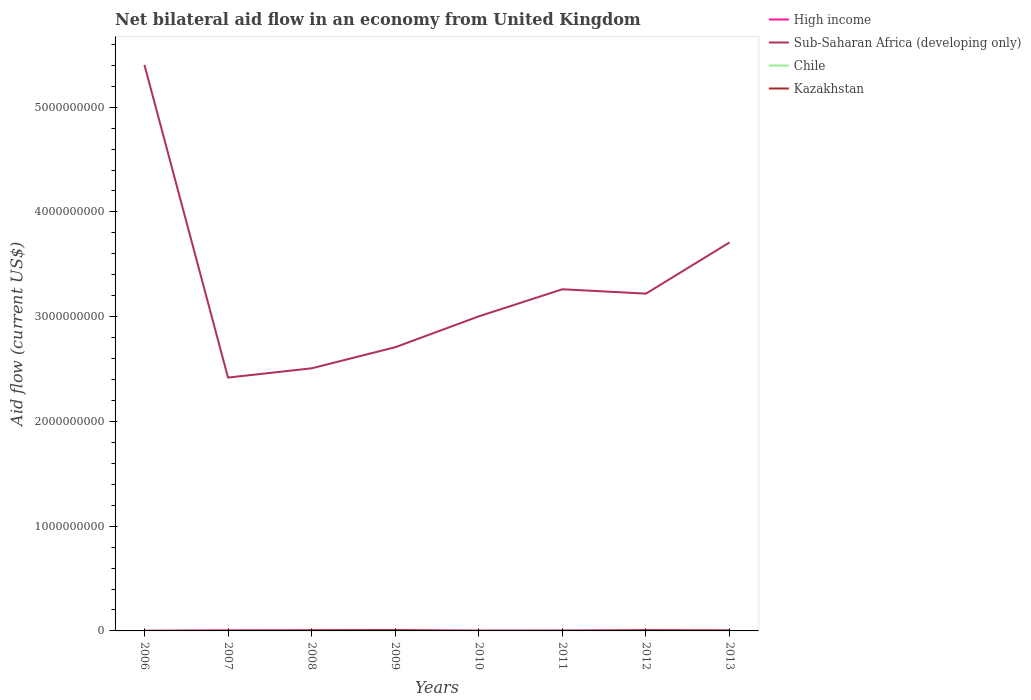Does the line corresponding to Kazakhstan intersect with the line corresponding to High income?
Keep it short and to the point. Yes. What is the total net bilateral aid flow in Chile in the graph?
Offer a terse response. -7.00e+04. What is the difference between the highest and the second highest net bilateral aid flow in Sub-Saharan Africa (developing only)?
Offer a terse response. 2.99e+09. Is the net bilateral aid flow in Kazakhstan strictly greater than the net bilateral aid flow in Sub-Saharan Africa (developing only) over the years?
Give a very brief answer. Yes. What is the difference between two consecutive major ticks on the Y-axis?
Keep it short and to the point. 1.00e+09. How many legend labels are there?
Keep it short and to the point. 4. How are the legend labels stacked?
Your answer should be compact. Vertical. What is the title of the graph?
Make the answer very short. Net bilateral aid flow in an economy from United Kingdom. What is the label or title of the X-axis?
Offer a terse response. Years. What is the label or title of the Y-axis?
Provide a succinct answer. Aid flow (current US$). What is the Aid flow (current US$) of High income in 2006?
Your answer should be compact. 1.64e+06. What is the Aid flow (current US$) in Sub-Saharan Africa (developing only) in 2006?
Provide a short and direct response. 5.40e+09. What is the Aid flow (current US$) of Chile in 2006?
Offer a terse response. 8.60e+05. What is the Aid flow (current US$) of High income in 2007?
Provide a short and direct response. 5.97e+06. What is the Aid flow (current US$) of Sub-Saharan Africa (developing only) in 2007?
Ensure brevity in your answer.  2.42e+09. What is the Aid flow (current US$) in Chile in 2007?
Your answer should be very brief. 5.20e+05. What is the Aid flow (current US$) in High income in 2008?
Your response must be concise. 3.69e+06. What is the Aid flow (current US$) of Sub-Saharan Africa (developing only) in 2008?
Your answer should be very brief. 2.51e+09. What is the Aid flow (current US$) of Kazakhstan in 2008?
Provide a short and direct response. 5.42e+06. What is the Aid flow (current US$) of High income in 2009?
Your response must be concise. 4.25e+06. What is the Aid flow (current US$) of Sub-Saharan Africa (developing only) in 2009?
Offer a very short reply. 2.71e+09. What is the Aid flow (current US$) in Chile in 2009?
Offer a very short reply. 5.90e+05. What is the Aid flow (current US$) of Kazakhstan in 2009?
Your response must be concise. 6.95e+06. What is the Aid flow (current US$) of High income in 2010?
Provide a short and direct response. 3.12e+06. What is the Aid flow (current US$) of Sub-Saharan Africa (developing only) in 2010?
Your response must be concise. 3.00e+09. What is the Aid flow (current US$) of Kazakhstan in 2010?
Your response must be concise. 3.40e+05. What is the Aid flow (current US$) in High income in 2011?
Your response must be concise. 1.04e+06. What is the Aid flow (current US$) of Sub-Saharan Africa (developing only) in 2011?
Provide a succinct answer. 3.26e+09. What is the Aid flow (current US$) in Chile in 2011?
Your answer should be very brief. 5.50e+05. What is the Aid flow (current US$) in Kazakhstan in 2011?
Keep it short and to the point. 2.73e+06. What is the Aid flow (current US$) in High income in 2012?
Your response must be concise. 5.89e+06. What is the Aid flow (current US$) of Sub-Saharan Africa (developing only) in 2012?
Give a very brief answer. 3.22e+09. What is the Aid flow (current US$) of Chile in 2012?
Offer a terse response. 1.40e+06. What is the Aid flow (current US$) in Kazakhstan in 2012?
Your answer should be compact. 5.22e+06. What is the Aid flow (current US$) of High income in 2013?
Offer a very short reply. 6.59e+06. What is the Aid flow (current US$) of Sub-Saharan Africa (developing only) in 2013?
Offer a terse response. 3.71e+09. What is the Aid flow (current US$) in Chile in 2013?
Offer a very short reply. 3.09e+06. What is the Aid flow (current US$) in Kazakhstan in 2013?
Offer a terse response. 2.80e+06. Across all years, what is the maximum Aid flow (current US$) of High income?
Give a very brief answer. 6.59e+06. Across all years, what is the maximum Aid flow (current US$) in Sub-Saharan Africa (developing only)?
Your answer should be compact. 5.40e+09. Across all years, what is the maximum Aid flow (current US$) of Chile?
Provide a short and direct response. 3.09e+06. Across all years, what is the maximum Aid flow (current US$) in Kazakhstan?
Provide a short and direct response. 6.95e+06. Across all years, what is the minimum Aid flow (current US$) of High income?
Provide a short and direct response. 1.04e+06. Across all years, what is the minimum Aid flow (current US$) in Sub-Saharan Africa (developing only)?
Your answer should be compact. 2.42e+09. Across all years, what is the minimum Aid flow (current US$) in Chile?
Provide a short and direct response. 4.80e+05. What is the total Aid flow (current US$) of High income in the graph?
Provide a succinct answer. 3.22e+07. What is the total Aid flow (current US$) in Sub-Saharan Africa (developing only) in the graph?
Offer a terse response. 2.62e+1. What is the total Aid flow (current US$) in Chile in the graph?
Give a very brief answer. 8.15e+06. What is the total Aid flow (current US$) in Kazakhstan in the graph?
Ensure brevity in your answer.  2.43e+07. What is the difference between the Aid flow (current US$) in High income in 2006 and that in 2007?
Make the answer very short. -4.33e+06. What is the difference between the Aid flow (current US$) in Sub-Saharan Africa (developing only) in 2006 and that in 2007?
Ensure brevity in your answer.  2.99e+09. What is the difference between the Aid flow (current US$) of Chile in 2006 and that in 2007?
Offer a terse response. 3.40e+05. What is the difference between the Aid flow (current US$) in Kazakhstan in 2006 and that in 2007?
Your answer should be very brief. -4.90e+05. What is the difference between the Aid flow (current US$) in High income in 2006 and that in 2008?
Offer a very short reply. -2.05e+06. What is the difference between the Aid flow (current US$) of Sub-Saharan Africa (developing only) in 2006 and that in 2008?
Your answer should be very brief. 2.90e+09. What is the difference between the Aid flow (current US$) in Kazakhstan in 2006 and that in 2008?
Ensure brevity in your answer.  -5.25e+06. What is the difference between the Aid flow (current US$) in High income in 2006 and that in 2009?
Your response must be concise. -2.61e+06. What is the difference between the Aid flow (current US$) in Sub-Saharan Africa (developing only) in 2006 and that in 2009?
Make the answer very short. 2.70e+09. What is the difference between the Aid flow (current US$) in Kazakhstan in 2006 and that in 2009?
Your answer should be compact. -6.78e+06. What is the difference between the Aid flow (current US$) in High income in 2006 and that in 2010?
Provide a short and direct response. -1.48e+06. What is the difference between the Aid flow (current US$) of Sub-Saharan Africa (developing only) in 2006 and that in 2010?
Offer a very short reply. 2.40e+09. What is the difference between the Aid flow (current US$) in Kazakhstan in 2006 and that in 2010?
Provide a succinct answer. -1.70e+05. What is the difference between the Aid flow (current US$) in High income in 2006 and that in 2011?
Make the answer very short. 6.00e+05. What is the difference between the Aid flow (current US$) of Sub-Saharan Africa (developing only) in 2006 and that in 2011?
Provide a succinct answer. 2.14e+09. What is the difference between the Aid flow (current US$) of Chile in 2006 and that in 2011?
Make the answer very short. 3.10e+05. What is the difference between the Aid flow (current US$) in Kazakhstan in 2006 and that in 2011?
Offer a terse response. -2.56e+06. What is the difference between the Aid flow (current US$) in High income in 2006 and that in 2012?
Your response must be concise. -4.25e+06. What is the difference between the Aid flow (current US$) of Sub-Saharan Africa (developing only) in 2006 and that in 2012?
Your answer should be compact. 2.18e+09. What is the difference between the Aid flow (current US$) in Chile in 2006 and that in 2012?
Keep it short and to the point. -5.40e+05. What is the difference between the Aid flow (current US$) of Kazakhstan in 2006 and that in 2012?
Give a very brief answer. -5.05e+06. What is the difference between the Aid flow (current US$) in High income in 2006 and that in 2013?
Offer a terse response. -4.95e+06. What is the difference between the Aid flow (current US$) of Sub-Saharan Africa (developing only) in 2006 and that in 2013?
Offer a terse response. 1.69e+09. What is the difference between the Aid flow (current US$) of Chile in 2006 and that in 2013?
Offer a terse response. -2.23e+06. What is the difference between the Aid flow (current US$) of Kazakhstan in 2006 and that in 2013?
Provide a succinct answer. -2.63e+06. What is the difference between the Aid flow (current US$) of High income in 2007 and that in 2008?
Give a very brief answer. 2.28e+06. What is the difference between the Aid flow (current US$) in Sub-Saharan Africa (developing only) in 2007 and that in 2008?
Give a very brief answer. -8.83e+07. What is the difference between the Aid flow (current US$) of Kazakhstan in 2007 and that in 2008?
Provide a succinct answer. -4.76e+06. What is the difference between the Aid flow (current US$) of High income in 2007 and that in 2009?
Keep it short and to the point. 1.72e+06. What is the difference between the Aid flow (current US$) of Sub-Saharan Africa (developing only) in 2007 and that in 2009?
Offer a terse response. -2.90e+08. What is the difference between the Aid flow (current US$) of Kazakhstan in 2007 and that in 2009?
Your answer should be very brief. -6.29e+06. What is the difference between the Aid flow (current US$) in High income in 2007 and that in 2010?
Give a very brief answer. 2.85e+06. What is the difference between the Aid flow (current US$) in Sub-Saharan Africa (developing only) in 2007 and that in 2010?
Offer a terse response. -5.85e+08. What is the difference between the Aid flow (current US$) of High income in 2007 and that in 2011?
Make the answer very short. 4.93e+06. What is the difference between the Aid flow (current US$) of Sub-Saharan Africa (developing only) in 2007 and that in 2011?
Provide a succinct answer. -8.43e+08. What is the difference between the Aid flow (current US$) of Chile in 2007 and that in 2011?
Give a very brief answer. -3.00e+04. What is the difference between the Aid flow (current US$) of Kazakhstan in 2007 and that in 2011?
Offer a very short reply. -2.07e+06. What is the difference between the Aid flow (current US$) of Sub-Saharan Africa (developing only) in 2007 and that in 2012?
Give a very brief answer. -8.01e+08. What is the difference between the Aid flow (current US$) in Chile in 2007 and that in 2012?
Provide a succinct answer. -8.80e+05. What is the difference between the Aid flow (current US$) of Kazakhstan in 2007 and that in 2012?
Your answer should be very brief. -4.56e+06. What is the difference between the Aid flow (current US$) in High income in 2007 and that in 2013?
Offer a terse response. -6.20e+05. What is the difference between the Aid flow (current US$) of Sub-Saharan Africa (developing only) in 2007 and that in 2013?
Your response must be concise. -1.29e+09. What is the difference between the Aid flow (current US$) of Chile in 2007 and that in 2013?
Your answer should be compact. -2.57e+06. What is the difference between the Aid flow (current US$) in Kazakhstan in 2007 and that in 2013?
Keep it short and to the point. -2.14e+06. What is the difference between the Aid flow (current US$) in High income in 2008 and that in 2009?
Your response must be concise. -5.60e+05. What is the difference between the Aid flow (current US$) in Sub-Saharan Africa (developing only) in 2008 and that in 2009?
Ensure brevity in your answer.  -2.01e+08. What is the difference between the Aid flow (current US$) in Kazakhstan in 2008 and that in 2009?
Provide a succinct answer. -1.53e+06. What is the difference between the Aid flow (current US$) of High income in 2008 and that in 2010?
Provide a short and direct response. 5.70e+05. What is the difference between the Aid flow (current US$) of Sub-Saharan Africa (developing only) in 2008 and that in 2010?
Make the answer very short. -4.96e+08. What is the difference between the Aid flow (current US$) of Kazakhstan in 2008 and that in 2010?
Provide a short and direct response. 5.08e+06. What is the difference between the Aid flow (current US$) of High income in 2008 and that in 2011?
Ensure brevity in your answer.  2.65e+06. What is the difference between the Aid flow (current US$) of Sub-Saharan Africa (developing only) in 2008 and that in 2011?
Offer a terse response. -7.55e+08. What is the difference between the Aid flow (current US$) in Kazakhstan in 2008 and that in 2011?
Ensure brevity in your answer.  2.69e+06. What is the difference between the Aid flow (current US$) in High income in 2008 and that in 2012?
Offer a very short reply. -2.20e+06. What is the difference between the Aid flow (current US$) in Sub-Saharan Africa (developing only) in 2008 and that in 2012?
Provide a succinct answer. -7.13e+08. What is the difference between the Aid flow (current US$) in Chile in 2008 and that in 2012?
Ensure brevity in your answer.  -9.20e+05. What is the difference between the Aid flow (current US$) of High income in 2008 and that in 2013?
Make the answer very short. -2.90e+06. What is the difference between the Aid flow (current US$) of Sub-Saharan Africa (developing only) in 2008 and that in 2013?
Ensure brevity in your answer.  -1.20e+09. What is the difference between the Aid flow (current US$) in Chile in 2008 and that in 2013?
Offer a terse response. -2.61e+06. What is the difference between the Aid flow (current US$) in Kazakhstan in 2008 and that in 2013?
Give a very brief answer. 2.62e+06. What is the difference between the Aid flow (current US$) in High income in 2009 and that in 2010?
Give a very brief answer. 1.13e+06. What is the difference between the Aid flow (current US$) of Sub-Saharan Africa (developing only) in 2009 and that in 2010?
Give a very brief answer. -2.95e+08. What is the difference between the Aid flow (current US$) in Kazakhstan in 2009 and that in 2010?
Provide a succinct answer. 6.61e+06. What is the difference between the Aid flow (current US$) in High income in 2009 and that in 2011?
Your answer should be very brief. 3.21e+06. What is the difference between the Aid flow (current US$) in Sub-Saharan Africa (developing only) in 2009 and that in 2011?
Ensure brevity in your answer.  -5.53e+08. What is the difference between the Aid flow (current US$) in Kazakhstan in 2009 and that in 2011?
Your answer should be very brief. 4.22e+06. What is the difference between the Aid flow (current US$) of High income in 2009 and that in 2012?
Provide a short and direct response. -1.64e+06. What is the difference between the Aid flow (current US$) of Sub-Saharan Africa (developing only) in 2009 and that in 2012?
Ensure brevity in your answer.  -5.12e+08. What is the difference between the Aid flow (current US$) of Chile in 2009 and that in 2012?
Provide a short and direct response. -8.10e+05. What is the difference between the Aid flow (current US$) in Kazakhstan in 2009 and that in 2012?
Make the answer very short. 1.73e+06. What is the difference between the Aid flow (current US$) in High income in 2009 and that in 2013?
Your answer should be compact. -2.34e+06. What is the difference between the Aid flow (current US$) of Sub-Saharan Africa (developing only) in 2009 and that in 2013?
Give a very brief answer. -1.00e+09. What is the difference between the Aid flow (current US$) in Chile in 2009 and that in 2013?
Offer a terse response. -2.50e+06. What is the difference between the Aid flow (current US$) in Kazakhstan in 2009 and that in 2013?
Give a very brief answer. 4.15e+06. What is the difference between the Aid flow (current US$) in High income in 2010 and that in 2011?
Ensure brevity in your answer.  2.08e+06. What is the difference between the Aid flow (current US$) in Sub-Saharan Africa (developing only) in 2010 and that in 2011?
Give a very brief answer. -2.59e+08. What is the difference between the Aid flow (current US$) in Chile in 2010 and that in 2011?
Make the answer very short. 1.10e+05. What is the difference between the Aid flow (current US$) of Kazakhstan in 2010 and that in 2011?
Offer a very short reply. -2.39e+06. What is the difference between the Aid flow (current US$) in High income in 2010 and that in 2012?
Provide a short and direct response. -2.77e+06. What is the difference between the Aid flow (current US$) of Sub-Saharan Africa (developing only) in 2010 and that in 2012?
Provide a short and direct response. -2.17e+08. What is the difference between the Aid flow (current US$) in Chile in 2010 and that in 2012?
Offer a very short reply. -7.40e+05. What is the difference between the Aid flow (current US$) in Kazakhstan in 2010 and that in 2012?
Provide a short and direct response. -4.88e+06. What is the difference between the Aid flow (current US$) of High income in 2010 and that in 2013?
Provide a short and direct response. -3.47e+06. What is the difference between the Aid flow (current US$) in Sub-Saharan Africa (developing only) in 2010 and that in 2013?
Give a very brief answer. -7.06e+08. What is the difference between the Aid flow (current US$) in Chile in 2010 and that in 2013?
Keep it short and to the point. -2.43e+06. What is the difference between the Aid flow (current US$) in Kazakhstan in 2010 and that in 2013?
Offer a very short reply. -2.46e+06. What is the difference between the Aid flow (current US$) of High income in 2011 and that in 2012?
Offer a very short reply. -4.85e+06. What is the difference between the Aid flow (current US$) in Sub-Saharan Africa (developing only) in 2011 and that in 2012?
Offer a very short reply. 4.16e+07. What is the difference between the Aid flow (current US$) in Chile in 2011 and that in 2012?
Make the answer very short. -8.50e+05. What is the difference between the Aid flow (current US$) in Kazakhstan in 2011 and that in 2012?
Keep it short and to the point. -2.49e+06. What is the difference between the Aid flow (current US$) of High income in 2011 and that in 2013?
Your answer should be compact. -5.55e+06. What is the difference between the Aid flow (current US$) in Sub-Saharan Africa (developing only) in 2011 and that in 2013?
Your answer should be compact. -4.47e+08. What is the difference between the Aid flow (current US$) of Chile in 2011 and that in 2013?
Give a very brief answer. -2.54e+06. What is the difference between the Aid flow (current US$) in Kazakhstan in 2011 and that in 2013?
Give a very brief answer. -7.00e+04. What is the difference between the Aid flow (current US$) in High income in 2012 and that in 2013?
Your response must be concise. -7.00e+05. What is the difference between the Aid flow (current US$) in Sub-Saharan Africa (developing only) in 2012 and that in 2013?
Make the answer very short. -4.89e+08. What is the difference between the Aid flow (current US$) in Chile in 2012 and that in 2013?
Offer a very short reply. -1.69e+06. What is the difference between the Aid flow (current US$) of Kazakhstan in 2012 and that in 2013?
Offer a very short reply. 2.42e+06. What is the difference between the Aid flow (current US$) in High income in 2006 and the Aid flow (current US$) in Sub-Saharan Africa (developing only) in 2007?
Your response must be concise. -2.42e+09. What is the difference between the Aid flow (current US$) of High income in 2006 and the Aid flow (current US$) of Chile in 2007?
Offer a very short reply. 1.12e+06. What is the difference between the Aid flow (current US$) of High income in 2006 and the Aid flow (current US$) of Kazakhstan in 2007?
Give a very brief answer. 9.80e+05. What is the difference between the Aid flow (current US$) in Sub-Saharan Africa (developing only) in 2006 and the Aid flow (current US$) in Chile in 2007?
Keep it short and to the point. 5.40e+09. What is the difference between the Aid flow (current US$) in Sub-Saharan Africa (developing only) in 2006 and the Aid flow (current US$) in Kazakhstan in 2007?
Offer a very short reply. 5.40e+09. What is the difference between the Aid flow (current US$) of Chile in 2006 and the Aid flow (current US$) of Kazakhstan in 2007?
Provide a succinct answer. 2.00e+05. What is the difference between the Aid flow (current US$) in High income in 2006 and the Aid flow (current US$) in Sub-Saharan Africa (developing only) in 2008?
Give a very brief answer. -2.51e+09. What is the difference between the Aid flow (current US$) in High income in 2006 and the Aid flow (current US$) in Chile in 2008?
Your answer should be compact. 1.16e+06. What is the difference between the Aid flow (current US$) in High income in 2006 and the Aid flow (current US$) in Kazakhstan in 2008?
Your answer should be compact. -3.78e+06. What is the difference between the Aid flow (current US$) in Sub-Saharan Africa (developing only) in 2006 and the Aid flow (current US$) in Chile in 2008?
Provide a succinct answer. 5.40e+09. What is the difference between the Aid flow (current US$) of Sub-Saharan Africa (developing only) in 2006 and the Aid flow (current US$) of Kazakhstan in 2008?
Keep it short and to the point. 5.40e+09. What is the difference between the Aid flow (current US$) in Chile in 2006 and the Aid flow (current US$) in Kazakhstan in 2008?
Make the answer very short. -4.56e+06. What is the difference between the Aid flow (current US$) of High income in 2006 and the Aid flow (current US$) of Sub-Saharan Africa (developing only) in 2009?
Your response must be concise. -2.71e+09. What is the difference between the Aid flow (current US$) in High income in 2006 and the Aid flow (current US$) in Chile in 2009?
Offer a very short reply. 1.05e+06. What is the difference between the Aid flow (current US$) of High income in 2006 and the Aid flow (current US$) of Kazakhstan in 2009?
Your response must be concise. -5.31e+06. What is the difference between the Aid flow (current US$) in Sub-Saharan Africa (developing only) in 2006 and the Aid flow (current US$) in Chile in 2009?
Give a very brief answer. 5.40e+09. What is the difference between the Aid flow (current US$) of Sub-Saharan Africa (developing only) in 2006 and the Aid flow (current US$) of Kazakhstan in 2009?
Provide a succinct answer. 5.40e+09. What is the difference between the Aid flow (current US$) in Chile in 2006 and the Aid flow (current US$) in Kazakhstan in 2009?
Offer a terse response. -6.09e+06. What is the difference between the Aid flow (current US$) in High income in 2006 and the Aid flow (current US$) in Sub-Saharan Africa (developing only) in 2010?
Provide a short and direct response. -3.00e+09. What is the difference between the Aid flow (current US$) of High income in 2006 and the Aid flow (current US$) of Chile in 2010?
Provide a short and direct response. 9.80e+05. What is the difference between the Aid flow (current US$) of High income in 2006 and the Aid flow (current US$) of Kazakhstan in 2010?
Offer a terse response. 1.30e+06. What is the difference between the Aid flow (current US$) of Sub-Saharan Africa (developing only) in 2006 and the Aid flow (current US$) of Chile in 2010?
Ensure brevity in your answer.  5.40e+09. What is the difference between the Aid flow (current US$) of Sub-Saharan Africa (developing only) in 2006 and the Aid flow (current US$) of Kazakhstan in 2010?
Your answer should be compact. 5.40e+09. What is the difference between the Aid flow (current US$) of Chile in 2006 and the Aid flow (current US$) of Kazakhstan in 2010?
Your answer should be very brief. 5.20e+05. What is the difference between the Aid flow (current US$) of High income in 2006 and the Aid flow (current US$) of Sub-Saharan Africa (developing only) in 2011?
Make the answer very short. -3.26e+09. What is the difference between the Aid flow (current US$) of High income in 2006 and the Aid flow (current US$) of Chile in 2011?
Provide a short and direct response. 1.09e+06. What is the difference between the Aid flow (current US$) of High income in 2006 and the Aid flow (current US$) of Kazakhstan in 2011?
Your answer should be very brief. -1.09e+06. What is the difference between the Aid flow (current US$) in Sub-Saharan Africa (developing only) in 2006 and the Aid flow (current US$) in Chile in 2011?
Give a very brief answer. 5.40e+09. What is the difference between the Aid flow (current US$) in Sub-Saharan Africa (developing only) in 2006 and the Aid flow (current US$) in Kazakhstan in 2011?
Offer a terse response. 5.40e+09. What is the difference between the Aid flow (current US$) of Chile in 2006 and the Aid flow (current US$) of Kazakhstan in 2011?
Provide a succinct answer. -1.87e+06. What is the difference between the Aid flow (current US$) in High income in 2006 and the Aid flow (current US$) in Sub-Saharan Africa (developing only) in 2012?
Give a very brief answer. -3.22e+09. What is the difference between the Aid flow (current US$) of High income in 2006 and the Aid flow (current US$) of Kazakhstan in 2012?
Provide a short and direct response. -3.58e+06. What is the difference between the Aid flow (current US$) in Sub-Saharan Africa (developing only) in 2006 and the Aid flow (current US$) in Chile in 2012?
Your response must be concise. 5.40e+09. What is the difference between the Aid flow (current US$) in Sub-Saharan Africa (developing only) in 2006 and the Aid flow (current US$) in Kazakhstan in 2012?
Your response must be concise. 5.40e+09. What is the difference between the Aid flow (current US$) in Chile in 2006 and the Aid flow (current US$) in Kazakhstan in 2012?
Offer a terse response. -4.36e+06. What is the difference between the Aid flow (current US$) of High income in 2006 and the Aid flow (current US$) of Sub-Saharan Africa (developing only) in 2013?
Ensure brevity in your answer.  -3.71e+09. What is the difference between the Aid flow (current US$) of High income in 2006 and the Aid flow (current US$) of Chile in 2013?
Make the answer very short. -1.45e+06. What is the difference between the Aid flow (current US$) in High income in 2006 and the Aid flow (current US$) in Kazakhstan in 2013?
Your answer should be compact. -1.16e+06. What is the difference between the Aid flow (current US$) in Sub-Saharan Africa (developing only) in 2006 and the Aid flow (current US$) in Chile in 2013?
Ensure brevity in your answer.  5.40e+09. What is the difference between the Aid flow (current US$) of Sub-Saharan Africa (developing only) in 2006 and the Aid flow (current US$) of Kazakhstan in 2013?
Your answer should be compact. 5.40e+09. What is the difference between the Aid flow (current US$) of Chile in 2006 and the Aid flow (current US$) of Kazakhstan in 2013?
Provide a succinct answer. -1.94e+06. What is the difference between the Aid flow (current US$) in High income in 2007 and the Aid flow (current US$) in Sub-Saharan Africa (developing only) in 2008?
Provide a succinct answer. -2.50e+09. What is the difference between the Aid flow (current US$) of High income in 2007 and the Aid flow (current US$) of Chile in 2008?
Give a very brief answer. 5.49e+06. What is the difference between the Aid flow (current US$) of Sub-Saharan Africa (developing only) in 2007 and the Aid flow (current US$) of Chile in 2008?
Offer a terse response. 2.42e+09. What is the difference between the Aid flow (current US$) of Sub-Saharan Africa (developing only) in 2007 and the Aid flow (current US$) of Kazakhstan in 2008?
Offer a very short reply. 2.41e+09. What is the difference between the Aid flow (current US$) of Chile in 2007 and the Aid flow (current US$) of Kazakhstan in 2008?
Provide a succinct answer. -4.90e+06. What is the difference between the Aid flow (current US$) of High income in 2007 and the Aid flow (current US$) of Sub-Saharan Africa (developing only) in 2009?
Your answer should be very brief. -2.70e+09. What is the difference between the Aid flow (current US$) of High income in 2007 and the Aid flow (current US$) of Chile in 2009?
Give a very brief answer. 5.38e+06. What is the difference between the Aid flow (current US$) in High income in 2007 and the Aid flow (current US$) in Kazakhstan in 2009?
Your answer should be compact. -9.80e+05. What is the difference between the Aid flow (current US$) of Sub-Saharan Africa (developing only) in 2007 and the Aid flow (current US$) of Chile in 2009?
Offer a very short reply. 2.42e+09. What is the difference between the Aid flow (current US$) in Sub-Saharan Africa (developing only) in 2007 and the Aid flow (current US$) in Kazakhstan in 2009?
Provide a short and direct response. 2.41e+09. What is the difference between the Aid flow (current US$) of Chile in 2007 and the Aid flow (current US$) of Kazakhstan in 2009?
Your response must be concise. -6.43e+06. What is the difference between the Aid flow (current US$) in High income in 2007 and the Aid flow (current US$) in Sub-Saharan Africa (developing only) in 2010?
Provide a succinct answer. -3.00e+09. What is the difference between the Aid flow (current US$) of High income in 2007 and the Aid flow (current US$) of Chile in 2010?
Offer a very short reply. 5.31e+06. What is the difference between the Aid flow (current US$) in High income in 2007 and the Aid flow (current US$) in Kazakhstan in 2010?
Your answer should be compact. 5.63e+06. What is the difference between the Aid flow (current US$) of Sub-Saharan Africa (developing only) in 2007 and the Aid flow (current US$) of Chile in 2010?
Ensure brevity in your answer.  2.42e+09. What is the difference between the Aid flow (current US$) of Sub-Saharan Africa (developing only) in 2007 and the Aid flow (current US$) of Kazakhstan in 2010?
Your answer should be compact. 2.42e+09. What is the difference between the Aid flow (current US$) of Chile in 2007 and the Aid flow (current US$) of Kazakhstan in 2010?
Your answer should be compact. 1.80e+05. What is the difference between the Aid flow (current US$) in High income in 2007 and the Aid flow (current US$) in Sub-Saharan Africa (developing only) in 2011?
Ensure brevity in your answer.  -3.26e+09. What is the difference between the Aid flow (current US$) of High income in 2007 and the Aid flow (current US$) of Chile in 2011?
Provide a succinct answer. 5.42e+06. What is the difference between the Aid flow (current US$) in High income in 2007 and the Aid flow (current US$) in Kazakhstan in 2011?
Your answer should be compact. 3.24e+06. What is the difference between the Aid flow (current US$) in Sub-Saharan Africa (developing only) in 2007 and the Aid flow (current US$) in Chile in 2011?
Make the answer very short. 2.42e+09. What is the difference between the Aid flow (current US$) of Sub-Saharan Africa (developing only) in 2007 and the Aid flow (current US$) of Kazakhstan in 2011?
Keep it short and to the point. 2.42e+09. What is the difference between the Aid flow (current US$) in Chile in 2007 and the Aid flow (current US$) in Kazakhstan in 2011?
Your response must be concise. -2.21e+06. What is the difference between the Aid flow (current US$) in High income in 2007 and the Aid flow (current US$) in Sub-Saharan Africa (developing only) in 2012?
Provide a succinct answer. -3.21e+09. What is the difference between the Aid flow (current US$) in High income in 2007 and the Aid flow (current US$) in Chile in 2012?
Make the answer very short. 4.57e+06. What is the difference between the Aid flow (current US$) in High income in 2007 and the Aid flow (current US$) in Kazakhstan in 2012?
Make the answer very short. 7.50e+05. What is the difference between the Aid flow (current US$) in Sub-Saharan Africa (developing only) in 2007 and the Aid flow (current US$) in Chile in 2012?
Keep it short and to the point. 2.42e+09. What is the difference between the Aid flow (current US$) in Sub-Saharan Africa (developing only) in 2007 and the Aid flow (current US$) in Kazakhstan in 2012?
Your response must be concise. 2.41e+09. What is the difference between the Aid flow (current US$) in Chile in 2007 and the Aid flow (current US$) in Kazakhstan in 2012?
Offer a very short reply. -4.70e+06. What is the difference between the Aid flow (current US$) of High income in 2007 and the Aid flow (current US$) of Sub-Saharan Africa (developing only) in 2013?
Offer a very short reply. -3.70e+09. What is the difference between the Aid flow (current US$) in High income in 2007 and the Aid flow (current US$) in Chile in 2013?
Give a very brief answer. 2.88e+06. What is the difference between the Aid flow (current US$) of High income in 2007 and the Aid flow (current US$) of Kazakhstan in 2013?
Your answer should be compact. 3.17e+06. What is the difference between the Aid flow (current US$) of Sub-Saharan Africa (developing only) in 2007 and the Aid flow (current US$) of Chile in 2013?
Your answer should be compact. 2.42e+09. What is the difference between the Aid flow (current US$) in Sub-Saharan Africa (developing only) in 2007 and the Aid flow (current US$) in Kazakhstan in 2013?
Your response must be concise. 2.42e+09. What is the difference between the Aid flow (current US$) in Chile in 2007 and the Aid flow (current US$) in Kazakhstan in 2013?
Your answer should be very brief. -2.28e+06. What is the difference between the Aid flow (current US$) of High income in 2008 and the Aid flow (current US$) of Sub-Saharan Africa (developing only) in 2009?
Your answer should be compact. -2.70e+09. What is the difference between the Aid flow (current US$) of High income in 2008 and the Aid flow (current US$) of Chile in 2009?
Provide a succinct answer. 3.10e+06. What is the difference between the Aid flow (current US$) of High income in 2008 and the Aid flow (current US$) of Kazakhstan in 2009?
Make the answer very short. -3.26e+06. What is the difference between the Aid flow (current US$) of Sub-Saharan Africa (developing only) in 2008 and the Aid flow (current US$) of Chile in 2009?
Make the answer very short. 2.51e+09. What is the difference between the Aid flow (current US$) of Sub-Saharan Africa (developing only) in 2008 and the Aid flow (current US$) of Kazakhstan in 2009?
Keep it short and to the point. 2.50e+09. What is the difference between the Aid flow (current US$) in Chile in 2008 and the Aid flow (current US$) in Kazakhstan in 2009?
Give a very brief answer. -6.47e+06. What is the difference between the Aid flow (current US$) in High income in 2008 and the Aid flow (current US$) in Sub-Saharan Africa (developing only) in 2010?
Offer a terse response. -3.00e+09. What is the difference between the Aid flow (current US$) of High income in 2008 and the Aid flow (current US$) of Chile in 2010?
Your answer should be very brief. 3.03e+06. What is the difference between the Aid flow (current US$) of High income in 2008 and the Aid flow (current US$) of Kazakhstan in 2010?
Provide a succinct answer. 3.35e+06. What is the difference between the Aid flow (current US$) of Sub-Saharan Africa (developing only) in 2008 and the Aid flow (current US$) of Chile in 2010?
Your answer should be very brief. 2.51e+09. What is the difference between the Aid flow (current US$) in Sub-Saharan Africa (developing only) in 2008 and the Aid flow (current US$) in Kazakhstan in 2010?
Give a very brief answer. 2.51e+09. What is the difference between the Aid flow (current US$) in High income in 2008 and the Aid flow (current US$) in Sub-Saharan Africa (developing only) in 2011?
Make the answer very short. -3.26e+09. What is the difference between the Aid flow (current US$) in High income in 2008 and the Aid flow (current US$) in Chile in 2011?
Your answer should be compact. 3.14e+06. What is the difference between the Aid flow (current US$) of High income in 2008 and the Aid flow (current US$) of Kazakhstan in 2011?
Offer a very short reply. 9.60e+05. What is the difference between the Aid flow (current US$) in Sub-Saharan Africa (developing only) in 2008 and the Aid flow (current US$) in Chile in 2011?
Give a very brief answer. 2.51e+09. What is the difference between the Aid flow (current US$) of Sub-Saharan Africa (developing only) in 2008 and the Aid flow (current US$) of Kazakhstan in 2011?
Provide a succinct answer. 2.50e+09. What is the difference between the Aid flow (current US$) in Chile in 2008 and the Aid flow (current US$) in Kazakhstan in 2011?
Offer a very short reply. -2.25e+06. What is the difference between the Aid flow (current US$) in High income in 2008 and the Aid flow (current US$) in Sub-Saharan Africa (developing only) in 2012?
Provide a succinct answer. -3.22e+09. What is the difference between the Aid flow (current US$) of High income in 2008 and the Aid flow (current US$) of Chile in 2012?
Provide a succinct answer. 2.29e+06. What is the difference between the Aid flow (current US$) in High income in 2008 and the Aid flow (current US$) in Kazakhstan in 2012?
Provide a short and direct response. -1.53e+06. What is the difference between the Aid flow (current US$) in Sub-Saharan Africa (developing only) in 2008 and the Aid flow (current US$) in Chile in 2012?
Give a very brief answer. 2.51e+09. What is the difference between the Aid flow (current US$) in Sub-Saharan Africa (developing only) in 2008 and the Aid flow (current US$) in Kazakhstan in 2012?
Offer a very short reply. 2.50e+09. What is the difference between the Aid flow (current US$) in Chile in 2008 and the Aid flow (current US$) in Kazakhstan in 2012?
Your response must be concise. -4.74e+06. What is the difference between the Aid flow (current US$) in High income in 2008 and the Aid flow (current US$) in Sub-Saharan Africa (developing only) in 2013?
Offer a very short reply. -3.71e+09. What is the difference between the Aid flow (current US$) of High income in 2008 and the Aid flow (current US$) of Kazakhstan in 2013?
Provide a succinct answer. 8.90e+05. What is the difference between the Aid flow (current US$) of Sub-Saharan Africa (developing only) in 2008 and the Aid flow (current US$) of Chile in 2013?
Make the answer very short. 2.50e+09. What is the difference between the Aid flow (current US$) of Sub-Saharan Africa (developing only) in 2008 and the Aid flow (current US$) of Kazakhstan in 2013?
Offer a terse response. 2.50e+09. What is the difference between the Aid flow (current US$) of Chile in 2008 and the Aid flow (current US$) of Kazakhstan in 2013?
Your answer should be very brief. -2.32e+06. What is the difference between the Aid flow (current US$) in High income in 2009 and the Aid flow (current US$) in Sub-Saharan Africa (developing only) in 2010?
Provide a succinct answer. -3.00e+09. What is the difference between the Aid flow (current US$) of High income in 2009 and the Aid flow (current US$) of Chile in 2010?
Provide a succinct answer. 3.59e+06. What is the difference between the Aid flow (current US$) of High income in 2009 and the Aid flow (current US$) of Kazakhstan in 2010?
Provide a short and direct response. 3.91e+06. What is the difference between the Aid flow (current US$) in Sub-Saharan Africa (developing only) in 2009 and the Aid flow (current US$) in Chile in 2010?
Your answer should be compact. 2.71e+09. What is the difference between the Aid flow (current US$) of Sub-Saharan Africa (developing only) in 2009 and the Aid flow (current US$) of Kazakhstan in 2010?
Offer a very short reply. 2.71e+09. What is the difference between the Aid flow (current US$) in Chile in 2009 and the Aid flow (current US$) in Kazakhstan in 2010?
Keep it short and to the point. 2.50e+05. What is the difference between the Aid flow (current US$) in High income in 2009 and the Aid flow (current US$) in Sub-Saharan Africa (developing only) in 2011?
Provide a short and direct response. -3.26e+09. What is the difference between the Aid flow (current US$) of High income in 2009 and the Aid flow (current US$) of Chile in 2011?
Keep it short and to the point. 3.70e+06. What is the difference between the Aid flow (current US$) of High income in 2009 and the Aid flow (current US$) of Kazakhstan in 2011?
Provide a short and direct response. 1.52e+06. What is the difference between the Aid flow (current US$) of Sub-Saharan Africa (developing only) in 2009 and the Aid flow (current US$) of Chile in 2011?
Ensure brevity in your answer.  2.71e+09. What is the difference between the Aid flow (current US$) of Sub-Saharan Africa (developing only) in 2009 and the Aid flow (current US$) of Kazakhstan in 2011?
Your answer should be very brief. 2.71e+09. What is the difference between the Aid flow (current US$) in Chile in 2009 and the Aid flow (current US$) in Kazakhstan in 2011?
Keep it short and to the point. -2.14e+06. What is the difference between the Aid flow (current US$) of High income in 2009 and the Aid flow (current US$) of Sub-Saharan Africa (developing only) in 2012?
Your answer should be very brief. -3.22e+09. What is the difference between the Aid flow (current US$) of High income in 2009 and the Aid flow (current US$) of Chile in 2012?
Ensure brevity in your answer.  2.85e+06. What is the difference between the Aid flow (current US$) in High income in 2009 and the Aid flow (current US$) in Kazakhstan in 2012?
Your response must be concise. -9.70e+05. What is the difference between the Aid flow (current US$) in Sub-Saharan Africa (developing only) in 2009 and the Aid flow (current US$) in Chile in 2012?
Offer a terse response. 2.71e+09. What is the difference between the Aid flow (current US$) of Sub-Saharan Africa (developing only) in 2009 and the Aid flow (current US$) of Kazakhstan in 2012?
Your answer should be very brief. 2.70e+09. What is the difference between the Aid flow (current US$) in Chile in 2009 and the Aid flow (current US$) in Kazakhstan in 2012?
Your answer should be very brief. -4.63e+06. What is the difference between the Aid flow (current US$) in High income in 2009 and the Aid flow (current US$) in Sub-Saharan Africa (developing only) in 2013?
Your answer should be compact. -3.70e+09. What is the difference between the Aid flow (current US$) of High income in 2009 and the Aid flow (current US$) of Chile in 2013?
Make the answer very short. 1.16e+06. What is the difference between the Aid flow (current US$) in High income in 2009 and the Aid flow (current US$) in Kazakhstan in 2013?
Give a very brief answer. 1.45e+06. What is the difference between the Aid flow (current US$) in Sub-Saharan Africa (developing only) in 2009 and the Aid flow (current US$) in Chile in 2013?
Provide a short and direct response. 2.71e+09. What is the difference between the Aid flow (current US$) in Sub-Saharan Africa (developing only) in 2009 and the Aid flow (current US$) in Kazakhstan in 2013?
Your answer should be very brief. 2.71e+09. What is the difference between the Aid flow (current US$) of Chile in 2009 and the Aid flow (current US$) of Kazakhstan in 2013?
Make the answer very short. -2.21e+06. What is the difference between the Aid flow (current US$) of High income in 2010 and the Aid flow (current US$) of Sub-Saharan Africa (developing only) in 2011?
Your answer should be compact. -3.26e+09. What is the difference between the Aid flow (current US$) in High income in 2010 and the Aid flow (current US$) in Chile in 2011?
Provide a short and direct response. 2.57e+06. What is the difference between the Aid flow (current US$) in High income in 2010 and the Aid flow (current US$) in Kazakhstan in 2011?
Keep it short and to the point. 3.90e+05. What is the difference between the Aid flow (current US$) in Sub-Saharan Africa (developing only) in 2010 and the Aid flow (current US$) in Chile in 2011?
Ensure brevity in your answer.  3.00e+09. What is the difference between the Aid flow (current US$) of Sub-Saharan Africa (developing only) in 2010 and the Aid flow (current US$) of Kazakhstan in 2011?
Your answer should be very brief. 3.00e+09. What is the difference between the Aid flow (current US$) in Chile in 2010 and the Aid flow (current US$) in Kazakhstan in 2011?
Your response must be concise. -2.07e+06. What is the difference between the Aid flow (current US$) of High income in 2010 and the Aid flow (current US$) of Sub-Saharan Africa (developing only) in 2012?
Your answer should be compact. -3.22e+09. What is the difference between the Aid flow (current US$) in High income in 2010 and the Aid flow (current US$) in Chile in 2012?
Provide a short and direct response. 1.72e+06. What is the difference between the Aid flow (current US$) of High income in 2010 and the Aid flow (current US$) of Kazakhstan in 2012?
Your answer should be compact. -2.10e+06. What is the difference between the Aid flow (current US$) in Sub-Saharan Africa (developing only) in 2010 and the Aid flow (current US$) in Chile in 2012?
Give a very brief answer. 3.00e+09. What is the difference between the Aid flow (current US$) in Sub-Saharan Africa (developing only) in 2010 and the Aid flow (current US$) in Kazakhstan in 2012?
Your answer should be very brief. 3.00e+09. What is the difference between the Aid flow (current US$) of Chile in 2010 and the Aid flow (current US$) of Kazakhstan in 2012?
Give a very brief answer. -4.56e+06. What is the difference between the Aid flow (current US$) of High income in 2010 and the Aid flow (current US$) of Sub-Saharan Africa (developing only) in 2013?
Offer a terse response. -3.71e+09. What is the difference between the Aid flow (current US$) of High income in 2010 and the Aid flow (current US$) of Chile in 2013?
Provide a succinct answer. 3.00e+04. What is the difference between the Aid flow (current US$) in High income in 2010 and the Aid flow (current US$) in Kazakhstan in 2013?
Ensure brevity in your answer.  3.20e+05. What is the difference between the Aid flow (current US$) in Sub-Saharan Africa (developing only) in 2010 and the Aid flow (current US$) in Chile in 2013?
Keep it short and to the point. 3.00e+09. What is the difference between the Aid flow (current US$) of Sub-Saharan Africa (developing only) in 2010 and the Aid flow (current US$) of Kazakhstan in 2013?
Provide a succinct answer. 3.00e+09. What is the difference between the Aid flow (current US$) in Chile in 2010 and the Aid flow (current US$) in Kazakhstan in 2013?
Offer a terse response. -2.14e+06. What is the difference between the Aid flow (current US$) of High income in 2011 and the Aid flow (current US$) of Sub-Saharan Africa (developing only) in 2012?
Your response must be concise. -3.22e+09. What is the difference between the Aid flow (current US$) of High income in 2011 and the Aid flow (current US$) of Chile in 2012?
Make the answer very short. -3.60e+05. What is the difference between the Aid flow (current US$) in High income in 2011 and the Aid flow (current US$) in Kazakhstan in 2012?
Provide a short and direct response. -4.18e+06. What is the difference between the Aid flow (current US$) of Sub-Saharan Africa (developing only) in 2011 and the Aid flow (current US$) of Chile in 2012?
Offer a terse response. 3.26e+09. What is the difference between the Aid flow (current US$) in Sub-Saharan Africa (developing only) in 2011 and the Aid flow (current US$) in Kazakhstan in 2012?
Offer a terse response. 3.26e+09. What is the difference between the Aid flow (current US$) in Chile in 2011 and the Aid flow (current US$) in Kazakhstan in 2012?
Give a very brief answer. -4.67e+06. What is the difference between the Aid flow (current US$) in High income in 2011 and the Aid flow (current US$) in Sub-Saharan Africa (developing only) in 2013?
Make the answer very short. -3.71e+09. What is the difference between the Aid flow (current US$) of High income in 2011 and the Aid flow (current US$) of Chile in 2013?
Keep it short and to the point. -2.05e+06. What is the difference between the Aid flow (current US$) in High income in 2011 and the Aid flow (current US$) in Kazakhstan in 2013?
Provide a succinct answer. -1.76e+06. What is the difference between the Aid flow (current US$) of Sub-Saharan Africa (developing only) in 2011 and the Aid flow (current US$) of Chile in 2013?
Your answer should be very brief. 3.26e+09. What is the difference between the Aid flow (current US$) in Sub-Saharan Africa (developing only) in 2011 and the Aid flow (current US$) in Kazakhstan in 2013?
Your answer should be compact. 3.26e+09. What is the difference between the Aid flow (current US$) of Chile in 2011 and the Aid flow (current US$) of Kazakhstan in 2013?
Your answer should be compact. -2.25e+06. What is the difference between the Aid flow (current US$) in High income in 2012 and the Aid flow (current US$) in Sub-Saharan Africa (developing only) in 2013?
Keep it short and to the point. -3.70e+09. What is the difference between the Aid flow (current US$) in High income in 2012 and the Aid flow (current US$) in Chile in 2013?
Provide a succinct answer. 2.80e+06. What is the difference between the Aid flow (current US$) of High income in 2012 and the Aid flow (current US$) of Kazakhstan in 2013?
Your answer should be compact. 3.09e+06. What is the difference between the Aid flow (current US$) of Sub-Saharan Africa (developing only) in 2012 and the Aid flow (current US$) of Chile in 2013?
Provide a short and direct response. 3.22e+09. What is the difference between the Aid flow (current US$) in Sub-Saharan Africa (developing only) in 2012 and the Aid flow (current US$) in Kazakhstan in 2013?
Your response must be concise. 3.22e+09. What is the difference between the Aid flow (current US$) in Chile in 2012 and the Aid flow (current US$) in Kazakhstan in 2013?
Make the answer very short. -1.40e+06. What is the average Aid flow (current US$) of High income per year?
Make the answer very short. 4.02e+06. What is the average Aid flow (current US$) in Sub-Saharan Africa (developing only) per year?
Make the answer very short. 3.28e+09. What is the average Aid flow (current US$) of Chile per year?
Keep it short and to the point. 1.02e+06. What is the average Aid flow (current US$) of Kazakhstan per year?
Ensure brevity in your answer.  3.04e+06. In the year 2006, what is the difference between the Aid flow (current US$) in High income and Aid flow (current US$) in Sub-Saharan Africa (developing only)?
Offer a very short reply. -5.40e+09. In the year 2006, what is the difference between the Aid flow (current US$) of High income and Aid flow (current US$) of Chile?
Provide a short and direct response. 7.80e+05. In the year 2006, what is the difference between the Aid flow (current US$) of High income and Aid flow (current US$) of Kazakhstan?
Provide a short and direct response. 1.47e+06. In the year 2006, what is the difference between the Aid flow (current US$) in Sub-Saharan Africa (developing only) and Aid flow (current US$) in Chile?
Make the answer very short. 5.40e+09. In the year 2006, what is the difference between the Aid flow (current US$) of Sub-Saharan Africa (developing only) and Aid flow (current US$) of Kazakhstan?
Your answer should be compact. 5.40e+09. In the year 2006, what is the difference between the Aid flow (current US$) of Chile and Aid flow (current US$) of Kazakhstan?
Your response must be concise. 6.90e+05. In the year 2007, what is the difference between the Aid flow (current US$) of High income and Aid flow (current US$) of Sub-Saharan Africa (developing only)?
Ensure brevity in your answer.  -2.41e+09. In the year 2007, what is the difference between the Aid flow (current US$) of High income and Aid flow (current US$) of Chile?
Keep it short and to the point. 5.45e+06. In the year 2007, what is the difference between the Aid flow (current US$) in High income and Aid flow (current US$) in Kazakhstan?
Ensure brevity in your answer.  5.31e+06. In the year 2007, what is the difference between the Aid flow (current US$) of Sub-Saharan Africa (developing only) and Aid flow (current US$) of Chile?
Provide a short and direct response. 2.42e+09. In the year 2007, what is the difference between the Aid flow (current US$) in Sub-Saharan Africa (developing only) and Aid flow (current US$) in Kazakhstan?
Provide a succinct answer. 2.42e+09. In the year 2008, what is the difference between the Aid flow (current US$) in High income and Aid flow (current US$) in Sub-Saharan Africa (developing only)?
Provide a short and direct response. -2.50e+09. In the year 2008, what is the difference between the Aid flow (current US$) in High income and Aid flow (current US$) in Chile?
Ensure brevity in your answer.  3.21e+06. In the year 2008, what is the difference between the Aid flow (current US$) of High income and Aid flow (current US$) of Kazakhstan?
Offer a very short reply. -1.73e+06. In the year 2008, what is the difference between the Aid flow (current US$) of Sub-Saharan Africa (developing only) and Aid flow (current US$) of Chile?
Offer a terse response. 2.51e+09. In the year 2008, what is the difference between the Aid flow (current US$) of Sub-Saharan Africa (developing only) and Aid flow (current US$) of Kazakhstan?
Your answer should be compact. 2.50e+09. In the year 2008, what is the difference between the Aid flow (current US$) in Chile and Aid flow (current US$) in Kazakhstan?
Provide a succinct answer. -4.94e+06. In the year 2009, what is the difference between the Aid flow (current US$) in High income and Aid flow (current US$) in Sub-Saharan Africa (developing only)?
Provide a short and direct response. -2.70e+09. In the year 2009, what is the difference between the Aid flow (current US$) of High income and Aid flow (current US$) of Chile?
Give a very brief answer. 3.66e+06. In the year 2009, what is the difference between the Aid flow (current US$) in High income and Aid flow (current US$) in Kazakhstan?
Make the answer very short. -2.70e+06. In the year 2009, what is the difference between the Aid flow (current US$) in Sub-Saharan Africa (developing only) and Aid flow (current US$) in Chile?
Ensure brevity in your answer.  2.71e+09. In the year 2009, what is the difference between the Aid flow (current US$) in Sub-Saharan Africa (developing only) and Aid flow (current US$) in Kazakhstan?
Give a very brief answer. 2.70e+09. In the year 2009, what is the difference between the Aid flow (current US$) in Chile and Aid flow (current US$) in Kazakhstan?
Ensure brevity in your answer.  -6.36e+06. In the year 2010, what is the difference between the Aid flow (current US$) in High income and Aid flow (current US$) in Sub-Saharan Africa (developing only)?
Your response must be concise. -3.00e+09. In the year 2010, what is the difference between the Aid flow (current US$) in High income and Aid flow (current US$) in Chile?
Give a very brief answer. 2.46e+06. In the year 2010, what is the difference between the Aid flow (current US$) in High income and Aid flow (current US$) in Kazakhstan?
Make the answer very short. 2.78e+06. In the year 2010, what is the difference between the Aid flow (current US$) of Sub-Saharan Africa (developing only) and Aid flow (current US$) of Chile?
Offer a very short reply. 3.00e+09. In the year 2010, what is the difference between the Aid flow (current US$) in Sub-Saharan Africa (developing only) and Aid flow (current US$) in Kazakhstan?
Give a very brief answer. 3.00e+09. In the year 2011, what is the difference between the Aid flow (current US$) of High income and Aid flow (current US$) of Sub-Saharan Africa (developing only)?
Ensure brevity in your answer.  -3.26e+09. In the year 2011, what is the difference between the Aid flow (current US$) of High income and Aid flow (current US$) of Chile?
Provide a short and direct response. 4.90e+05. In the year 2011, what is the difference between the Aid flow (current US$) in High income and Aid flow (current US$) in Kazakhstan?
Make the answer very short. -1.69e+06. In the year 2011, what is the difference between the Aid flow (current US$) of Sub-Saharan Africa (developing only) and Aid flow (current US$) of Chile?
Ensure brevity in your answer.  3.26e+09. In the year 2011, what is the difference between the Aid flow (current US$) in Sub-Saharan Africa (developing only) and Aid flow (current US$) in Kazakhstan?
Your answer should be compact. 3.26e+09. In the year 2011, what is the difference between the Aid flow (current US$) in Chile and Aid flow (current US$) in Kazakhstan?
Offer a very short reply. -2.18e+06. In the year 2012, what is the difference between the Aid flow (current US$) of High income and Aid flow (current US$) of Sub-Saharan Africa (developing only)?
Give a very brief answer. -3.21e+09. In the year 2012, what is the difference between the Aid flow (current US$) of High income and Aid flow (current US$) of Chile?
Offer a terse response. 4.49e+06. In the year 2012, what is the difference between the Aid flow (current US$) of High income and Aid flow (current US$) of Kazakhstan?
Make the answer very short. 6.70e+05. In the year 2012, what is the difference between the Aid flow (current US$) of Sub-Saharan Africa (developing only) and Aid flow (current US$) of Chile?
Your answer should be compact. 3.22e+09. In the year 2012, what is the difference between the Aid flow (current US$) in Sub-Saharan Africa (developing only) and Aid flow (current US$) in Kazakhstan?
Your answer should be compact. 3.21e+09. In the year 2012, what is the difference between the Aid flow (current US$) in Chile and Aid flow (current US$) in Kazakhstan?
Your answer should be very brief. -3.82e+06. In the year 2013, what is the difference between the Aid flow (current US$) in High income and Aid flow (current US$) in Sub-Saharan Africa (developing only)?
Offer a very short reply. -3.70e+09. In the year 2013, what is the difference between the Aid flow (current US$) in High income and Aid flow (current US$) in Chile?
Give a very brief answer. 3.50e+06. In the year 2013, what is the difference between the Aid flow (current US$) of High income and Aid flow (current US$) of Kazakhstan?
Offer a very short reply. 3.79e+06. In the year 2013, what is the difference between the Aid flow (current US$) of Sub-Saharan Africa (developing only) and Aid flow (current US$) of Chile?
Your answer should be compact. 3.71e+09. In the year 2013, what is the difference between the Aid flow (current US$) in Sub-Saharan Africa (developing only) and Aid flow (current US$) in Kazakhstan?
Offer a terse response. 3.71e+09. In the year 2013, what is the difference between the Aid flow (current US$) in Chile and Aid flow (current US$) in Kazakhstan?
Provide a short and direct response. 2.90e+05. What is the ratio of the Aid flow (current US$) of High income in 2006 to that in 2007?
Offer a very short reply. 0.27. What is the ratio of the Aid flow (current US$) in Sub-Saharan Africa (developing only) in 2006 to that in 2007?
Offer a terse response. 2.23. What is the ratio of the Aid flow (current US$) of Chile in 2006 to that in 2007?
Offer a very short reply. 1.65. What is the ratio of the Aid flow (current US$) of Kazakhstan in 2006 to that in 2007?
Offer a very short reply. 0.26. What is the ratio of the Aid flow (current US$) of High income in 2006 to that in 2008?
Provide a short and direct response. 0.44. What is the ratio of the Aid flow (current US$) in Sub-Saharan Africa (developing only) in 2006 to that in 2008?
Your response must be concise. 2.16. What is the ratio of the Aid flow (current US$) in Chile in 2006 to that in 2008?
Ensure brevity in your answer.  1.79. What is the ratio of the Aid flow (current US$) in Kazakhstan in 2006 to that in 2008?
Give a very brief answer. 0.03. What is the ratio of the Aid flow (current US$) in High income in 2006 to that in 2009?
Offer a terse response. 0.39. What is the ratio of the Aid flow (current US$) of Sub-Saharan Africa (developing only) in 2006 to that in 2009?
Offer a very short reply. 2. What is the ratio of the Aid flow (current US$) in Chile in 2006 to that in 2009?
Offer a very short reply. 1.46. What is the ratio of the Aid flow (current US$) in Kazakhstan in 2006 to that in 2009?
Give a very brief answer. 0.02. What is the ratio of the Aid flow (current US$) in High income in 2006 to that in 2010?
Offer a terse response. 0.53. What is the ratio of the Aid flow (current US$) in Sub-Saharan Africa (developing only) in 2006 to that in 2010?
Provide a succinct answer. 1.8. What is the ratio of the Aid flow (current US$) in Chile in 2006 to that in 2010?
Give a very brief answer. 1.3. What is the ratio of the Aid flow (current US$) of Kazakhstan in 2006 to that in 2010?
Provide a short and direct response. 0.5. What is the ratio of the Aid flow (current US$) in High income in 2006 to that in 2011?
Provide a short and direct response. 1.58. What is the ratio of the Aid flow (current US$) in Sub-Saharan Africa (developing only) in 2006 to that in 2011?
Your answer should be very brief. 1.66. What is the ratio of the Aid flow (current US$) of Chile in 2006 to that in 2011?
Offer a very short reply. 1.56. What is the ratio of the Aid flow (current US$) in Kazakhstan in 2006 to that in 2011?
Offer a very short reply. 0.06. What is the ratio of the Aid flow (current US$) of High income in 2006 to that in 2012?
Give a very brief answer. 0.28. What is the ratio of the Aid flow (current US$) in Sub-Saharan Africa (developing only) in 2006 to that in 2012?
Your response must be concise. 1.68. What is the ratio of the Aid flow (current US$) of Chile in 2006 to that in 2012?
Ensure brevity in your answer.  0.61. What is the ratio of the Aid flow (current US$) of Kazakhstan in 2006 to that in 2012?
Offer a terse response. 0.03. What is the ratio of the Aid flow (current US$) in High income in 2006 to that in 2013?
Provide a short and direct response. 0.25. What is the ratio of the Aid flow (current US$) in Sub-Saharan Africa (developing only) in 2006 to that in 2013?
Keep it short and to the point. 1.46. What is the ratio of the Aid flow (current US$) in Chile in 2006 to that in 2013?
Ensure brevity in your answer.  0.28. What is the ratio of the Aid flow (current US$) of Kazakhstan in 2006 to that in 2013?
Your answer should be compact. 0.06. What is the ratio of the Aid flow (current US$) in High income in 2007 to that in 2008?
Provide a succinct answer. 1.62. What is the ratio of the Aid flow (current US$) in Sub-Saharan Africa (developing only) in 2007 to that in 2008?
Provide a short and direct response. 0.96. What is the ratio of the Aid flow (current US$) of Kazakhstan in 2007 to that in 2008?
Offer a very short reply. 0.12. What is the ratio of the Aid flow (current US$) in High income in 2007 to that in 2009?
Provide a succinct answer. 1.4. What is the ratio of the Aid flow (current US$) in Sub-Saharan Africa (developing only) in 2007 to that in 2009?
Ensure brevity in your answer.  0.89. What is the ratio of the Aid flow (current US$) of Chile in 2007 to that in 2009?
Ensure brevity in your answer.  0.88. What is the ratio of the Aid flow (current US$) in Kazakhstan in 2007 to that in 2009?
Ensure brevity in your answer.  0.1. What is the ratio of the Aid flow (current US$) of High income in 2007 to that in 2010?
Provide a succinct answer. 1.91. What is the ratio of the Aid flow (current US$) of Sub-Saharan Africa (developing only) in 2007 to that in 2010?
Keep it short and to the point. 0.81. What is the ratio of the Aid flow (current US$) in Chile in 2007 to that in 2010?
Your answer should be compact. 0.79. What is the ratio of the Aid flow (current US$) in Kazakhstan in 2007 to that in 2010?
Your response must be concise. 1.94. What is the ratio of the Aid flow (current US$) in High income in 2007 to that in 2011?
Keep it short and to the point. 5.74. What is the ratio of the Aid flow (current US$) of Sub-Saharan Africa (developing only) in 2007 to that in 2011?
Give a very brief answer. 0.74. What is the ratio of the Aid flow (current US$) of Chile in 2007 to that in 2011?
Offer a terse response. 0.95. What is the ratio of the Aid flow (current US$) in Kazakhstan in 2007 to that in 2011?
Provide a succinct answer. 0.24. What is the ratio of the Aid flow (current US$) of High income in 2007 to that in 2012?
Provide a succinct answer. 1.01. What is the ratio of the Aid flow (current US$) in Sub-Saharan Africa (developing only) in 2007 to that in 2012?
Give a very brief answer. 0.75. What is the ratio of the Aid flow (current US$) of Chile in 2007 to that in 2012?
Offer a very short reply. 0.37. What is the ratio of the Aid flow (current US$) of Kazakhstan in 2007 to that in 2012?
Your response must be concise. 0.13. What is the ratio of the Aid flow (current US$) of High income in 2007 to that in 2013?
Ensure brevity in your answer.  0.91. What is the ratio of the Aid flow (current US$) in Sub-Saharan Africa (developing only) in 2007 to that in 2013?
Provide a succinct answer. 0.65. What is the ratio of the Aid flow (current US$) in Chile in 2007 to that in 2013?
Ensure brevity in your answer.  0.17. What is the ratio of the Aid flow (current US$) in Kazakhstan in 2007 to that in 2013?
Your answer should be very brief. 0.24. What is the ratio of the Aid flow (current US$) of High income in 2008 to that in 2009?
Your answer should be compact. 0.87. What is the ratio of the Aid flow (current US$) of Sub-Saharan Africa (developing only) in 2008 to that in 2009?
Provide a succinct answer. 0.93. What is the ratio of the Aid flow (current US$) of Chile in 2008 to that in 2009?
Offer a very short reply. 0.81. What is the ratio of the Aid flow (current US$) in Kazakhstan in 2008 to that in 2009?
Make the answer very short. 0.78. What is the ratio of the Aid flow (current US$) of High income in 2008 to that in 2010?
Your answer should be very brief. 1.18. What is the ratio of the Aid flow (current US$) of Sub-Saharan Africa (developing only) in 2008 to that in 2010?
Offer a terse response. 0.83. What is the ratio of the Aid flow (current US$) of Chile in 2008 to that in 2010?
Make the answer very short. 0.73. What is the ratio of the Aid flow (current US$) in Kazakhstan in 2008 to that in 2010?
Offer a very short reply. 15.94. What is the ratio of the Aid flow (current US$) of High income in 2008 to that in 2011?
Make the answer very short. 3.55. What is the ratio of the Aid flow (current US$) in Sub-Saharan Africa (developing only) in 2008 to that in 2011?
Offer a very short reply. 0.77. What is the ratio of the Aid flow (current US$) of Chile in 2008 to that in 2011?
Make the answer very short. 0.87. What is the ratio of the Aid flow (current US$) of Kazakhstan in 2008 to that in 2011?
Give a very brief answer. 1.99. What is the ratio of the Aid flow (current US$) in High income in 2008 to that in 2012?
Provide a succinct answer. 0.63. What is the ratio of the Aid flow (current US$) of Sub-Saharan Africa (developing only) in 2008 to that in 2012?
Give a very brief answer. 0.78. What is the ratio of the Aid flow (current US$) in Chile in 2008 to that in 2012?
Offer a very short reply. 0.34. What is the ratio of the Aid flow (current US$) in Kazakhstan in 2008 to that in 2012?
Give a very brief answer. 1.04. What is the ratio of the Aid flow (current US$) of High income in 2008 to that in 2013?
Ensure brevity in your answer.  0.56. What is the ratio of the Aid flow (current US$) in Sub-Saharan Africa (developing only) in 2008 to that in 2013?
Offer a very short reply. 0.68. What is the ratio of the Aid flow (current US$) in Chile in 2008 to that in 2013?
Give a very brief answer. 0.16. What is the ratio of the Aid flow (current US$) in Kazakhstan in 2008 to that in 2013?
Your answer should be very brief. 1.94. What is the ratio of the Aid flow (current US$) of High income in 2009 to that in 2010?
Offer a terse response. 1.36. What is the ratio of the Aid flow (current US$) of Sub-Saharan Africa (developing only) in 2009 to that in 2010?
Keep it short and to the point. 0.9. What is the ratio of the Aid flow (current US$) of Chile in 2009 to that in 2010?
Offer a terse response. 0.89. What is the ratio of the Aid flow (current US$) in Kazakhstan in 2009 to that in 2010?
Your answer should be compact. 20.44. What is the ratio of the Aid flow (current US$) of High income in 2009 to that in 2011?
Give a very brief answer. 4.09. What is the ratio of the Aid flow (current US$) of Sub-Saharan Africa (developing only) in 2009 to that in 2011?
Your answer should be very brief. 0.83. What is the ratio of the Aid flow (current US$) in Chile in 2009 to that in 2011?
Keep it short and to the point. 1.07. What is the ratio of the Aid flow (current US$) of Kazakhstan in 2009 to that in 2011?
Provide a short and direct response. 2.55. What is the ratio of the Aid flow (current US$) in High income in 2009 to that in 2012?
Give a very brief answer. 0.72. What is the ratio of the Aid flow (current US$) of Sub-Saharan Africa (developing only) in 2009 to that in 2012?
Ensure brevity in your answer.  0.84. What is the ratio of the Aid flow (current US$) of Chile in 2009 to that in 2012?
Give a very brief answer. 0.42. What is the ratio of the Aid flow (current US$) in Kazakhstan in 2009 to that in 2012?
Ensure brevity in your answer.  1.33. What is the ratio of the Aid flow (current US$) in High income in 2009 to that in 2013?
Ensure brevity in your answer.  0.64. What is the ratio of the Aid flow (current US$) of Sub-Saharan Africa (developing only) in 2009 to that in 2013?
Provide a short and direct response. 0.73. What is the ratio of the Aid flow (current US$) in Chile in 2009 to that in 2013?
Your answer should be compact. 0.19. What is the ratio of the Aid flow (current US$) in Kazakhstan in 2009 to that in 2013?
Your response must be concise. 2.48. What is the ratio of the Aid flow (current US$) of High income in 2010 to that in 2011?
Make the answer very short. 3. What is the ratio of the Aid flow (current US$) of Sub-Saharan Africa (developing only) in 2010 to that in 2011?
Ensure brevity in your answer.  0.92. What is the ratio of the Aid flow (current US$) of Chile in 2010 to that in 2011?
Give a very brief answer. 1.2. What is the ratio of the Aid flow (current US$) in Kazakhstan in 2010 to that in 2011?
Your answer should be very brief. 0.12. What is the ratio of the Aid flow (current US$) of High income in 2010 to that in 2012?
Offer a terse response. 0.53. What is the ratio of the Aid flow (current US$) of Sub-Saharan Africa (developing only) in 2010 to that in 2012?
Ensure brevity in your answer.  0.93. What is the ratio of the Aid flow (current US$) in Chile in 2010 to that in 2012?
Provide a short and direct response. 0.47. What is the ratio of the Aid flow (current US$) of Kazakhstan in 2010 to that in 2012?
Provide a succinct answer. 0.07. What is the ratio of the Aid flow (current US$) of High income in 2010 to that in 2013?
Provide a succinct answer. 0.47. What is the ratio of the Aid flow (current US$) in Sub-Saharan Africa (developing only) in 2010 to that in 2013?
Offer a very short reply. 0.81. What is the ratio of the Aid flow (current US$) of Chile in 2010 to that in 2013?
Your answer should be very brief. 0.21. What is the ratio of the Aid flow (current US$) of Kazakhstan in 2010 to that in 2013?
Offer a very short reply. 0.12. What is the ratio of the Aid flow (current US$) in High income in 2011 to that in 2012?
Provide a short and direct response. 0.18. What is the ratio of the Aid flow (current US$) in Sub-Saharan Africa (developing only) in 2011 to that in 2012?
Provide a succinct answer. 1.01. What is the ratio of the Aid flow (current US$) of Chile in 2011 to that in 2012?
Provide a short and direct response. 0.39. What is the ratio of the Aid flow (current US$) of Kazakhstan in 2011 to that in 2012?
Your answer should be very brief. 0.52. What is the ratio of the Aid flow (current US$) in High income in 2011 to that in 2013?
Give a very brief answer. 0.16. What is the ratio of the Aid flow (current US$) of Sub-Saharan Africa (developing only) in 2011 to that in 2013?
Give a very brief answer. 0.88. What is the ratio of the Aid flow (current US$) of Chile in 2011 to that in 2013?
Keep it short and to the point. 0.18. What is the ratio of the Aid flow (current US$) in High income in 2012 to that in 2013?
Give a very brief answer. 0.89. What is the ratio of the Aid flow (current US$) of Sub-Saharan Africa (developing only) in 2012 to that in 2013?
Give a very brief answer. 0.87. What is the ratio of the Aid flow (current US$) of Chile in 2012 to that in 2013?
Your response must be concise. 0.45. What is the ratio of the Aid flow (current US$) in Kazakhstan in 2012 to that in 2013?
Offer a very short reply. 1.86. What is the difference between the highest and the second highest Aid flow (current US$) of High income?
Your response must be concise. 6.20e+05. What is the difference between the highest and the second highest Aid flow (current US$) in Sub-Saharan Africa (developing only)?
Your response must be concise. 1.69e+09. What is the difference between the highest and the second highest Aid flow (current US$) of Chile?
Keep it short and to the point. 1.69e+06. What is the difference between the highest and the second highest Aid flow (current US$) in Kazakhstan?
Make the answer very short. 1.53e+06. What is the difference between the highest and the lowest Aid flow (current US$) of High income?
Ensure brevity in your answer.  5.55e+06. What is the difference between the highest and the lowest Aid flow (current US$) of Sub-Saharan Africa (developing only)?
Provide a short and direct response. 2.99e+09. What is the difference between the highest and the lowest Aid flow (current US$) in Chile?
Make the answer very short. 2.61e+06. What is the difference between the highest and the lowest Aid flow (current US$) of Kazakhstan?
Give a very brief answer. 6.78e+06. 